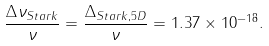<formula> <loc_0><loc_0><loc_500><loc_500>\frac { \Delta \nu _ { S t a r k } } { \nu } = \frac { \Delta _ { S t a r k , 5 D } } { \nu } = 1 . 3 7 \times 1 0 ^ { - 1 8 } .</formula> 